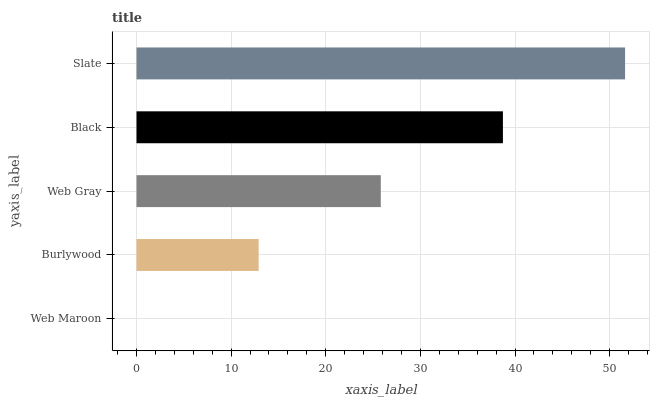Is Web Maroon the minimum?
Answer yes or no. Yes. Is Slate the maximum?
Answer yes or no. Yes. Is Burlywood the minimum?
Answer yes or no. No. Is Burlywood the maximum?
Answer yes or no. No. Is Burlywood greater than Web Maroon?
Answer yes or no. Yes. Is Web Maroon less than Burlywood?
Answer yes or no. Yes. Is Web Maroon greater than Burlywood?
Answer yes or no. No. Is Burlywood less than Web Maroon?
Answer yes or no. No. Is Web Gray the high median?
Answer yes or no. Yes. Is Web Gray the low median?
Answer yes or no. Yes. Is Black the high median?
Answer yes or no. No. Is Burlywood the low median?
Answer yes or no. No. 